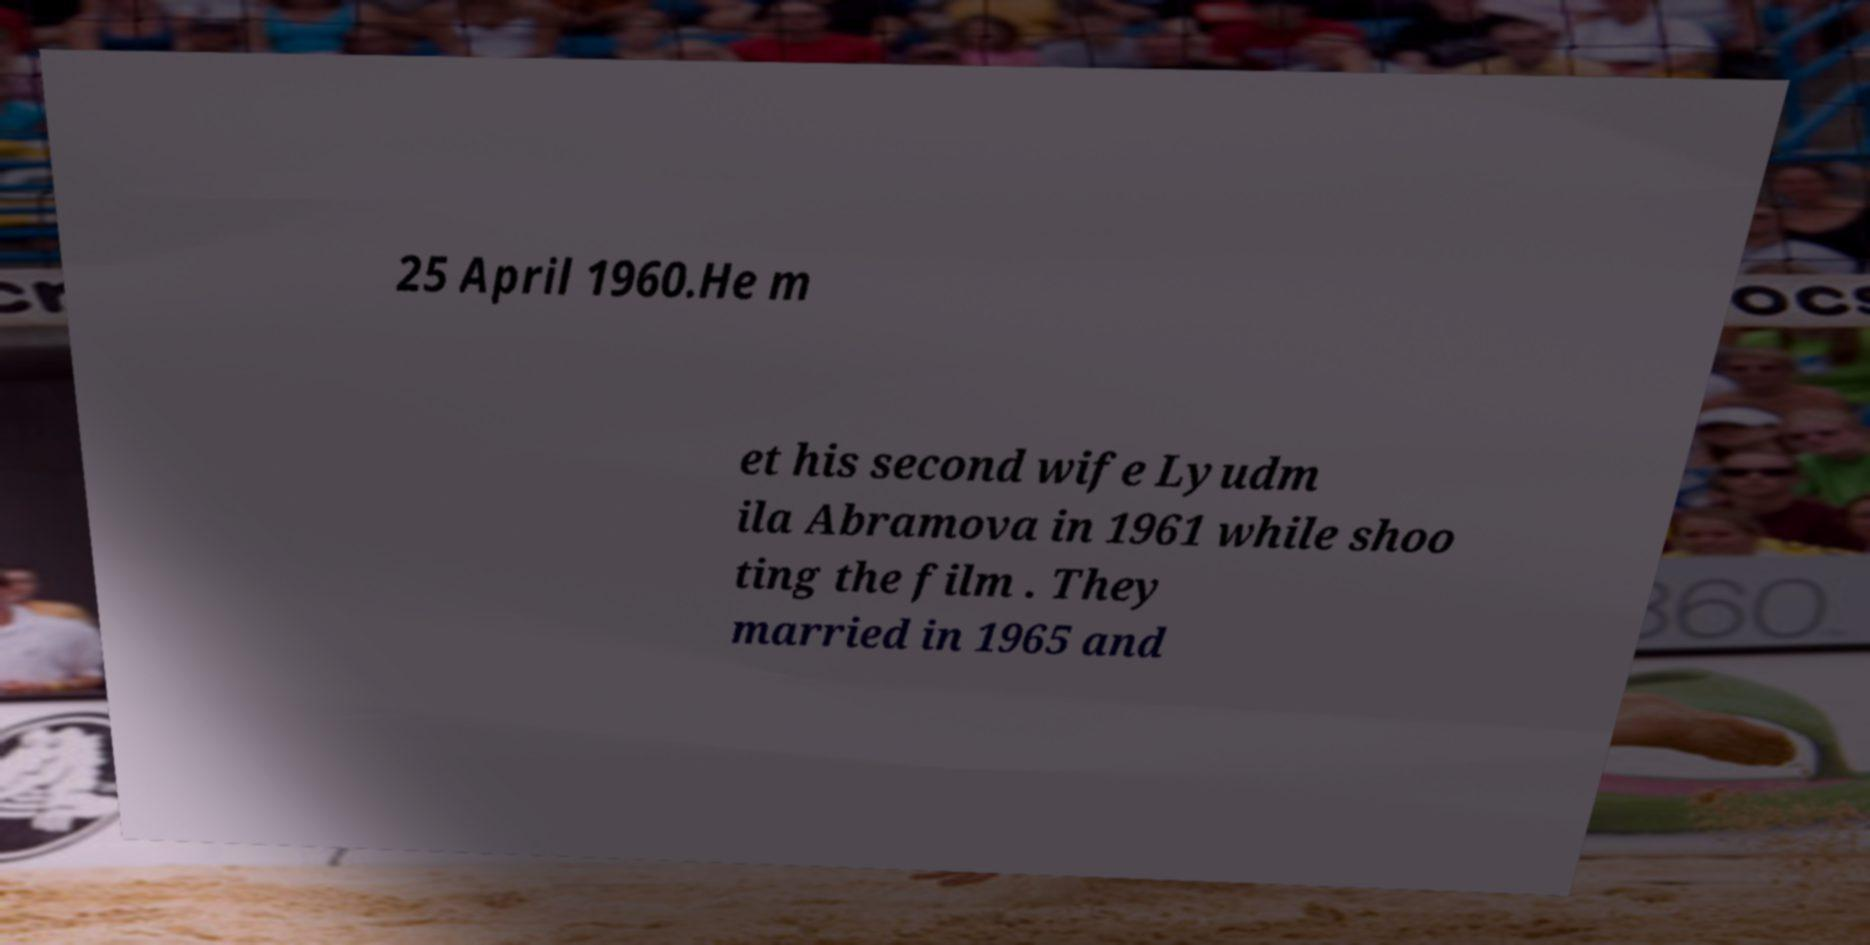Could you assist in decoding the text presented in this image and type it out clearly? 25 April 1960.He m et his second wife Lyudm ila Abramova in 1961 while shoo ting the film . They married in 1965 and 